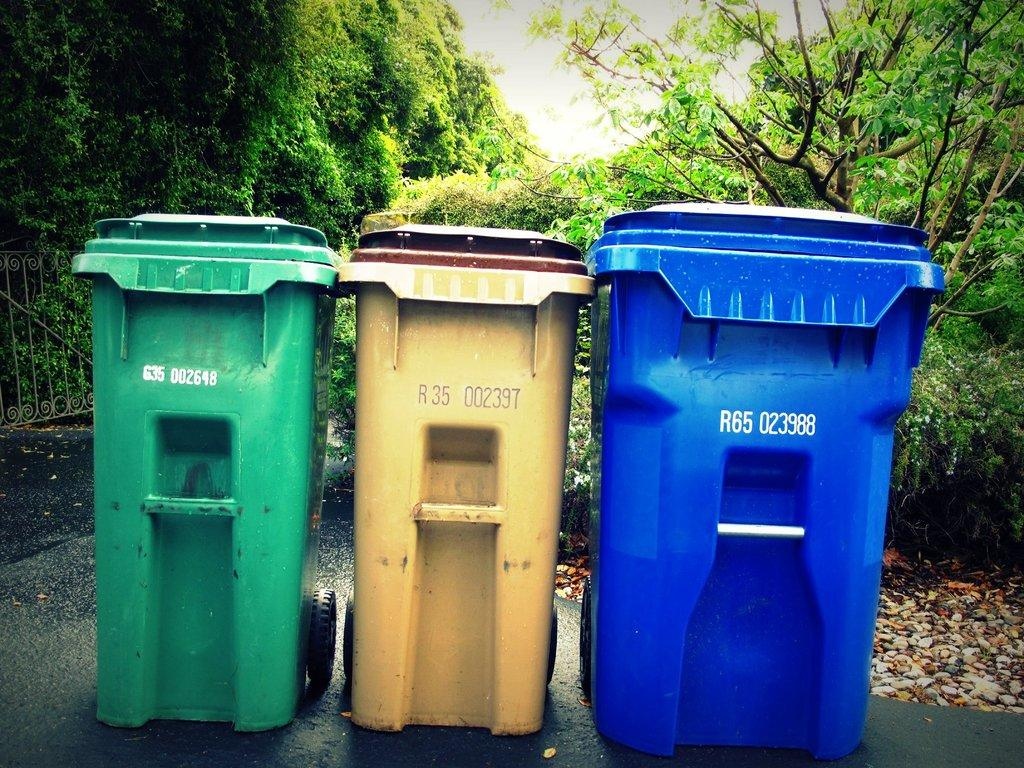<image>
Relay a brief, clear account of the picture shown. Three bins, the rightmost of which says R65 023988. 